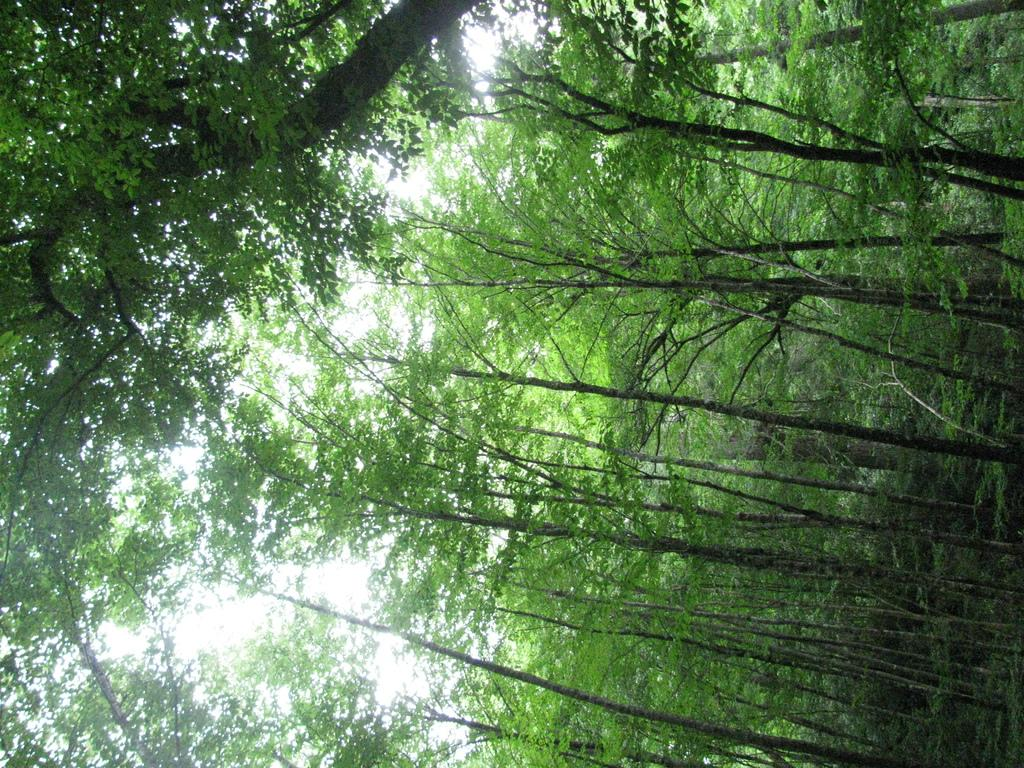What type of vegetation can be seen in the image? There are trees in the image. What part of the natural environment is visible in the image? The sky is visible in the background of the image. What type of sponge is being used to clean the engine in the image? There is no sponge or engine present in the image; it features trees and the sky. What type of experience can be gained from observing the image? The image does not convey a specific experience, as it only shows trees and the sky. 